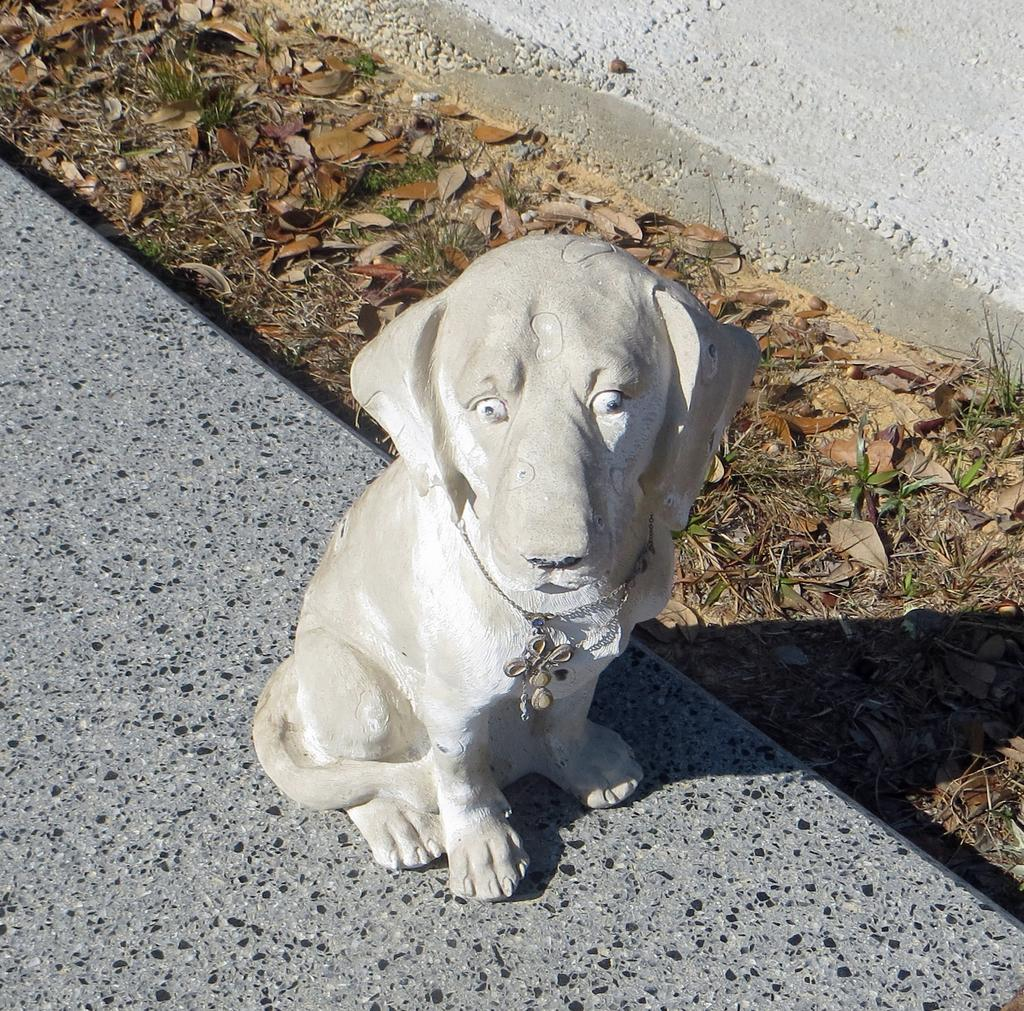What is the main subject in the center of the image? There is a statue in the center of the image. What type of surface is visible in the background of the image? There is pavement in the background of the image. What type of vegetation is present in the background of the image? Dry leaves and grass are present in the background of the image. What type of mask is being worn by the statue in the image? There is no mask present on the statue in the image. What rhythm is the statue dancing to in the image? The statue is not dancing in the image, so there is no rhythm associated with it. 